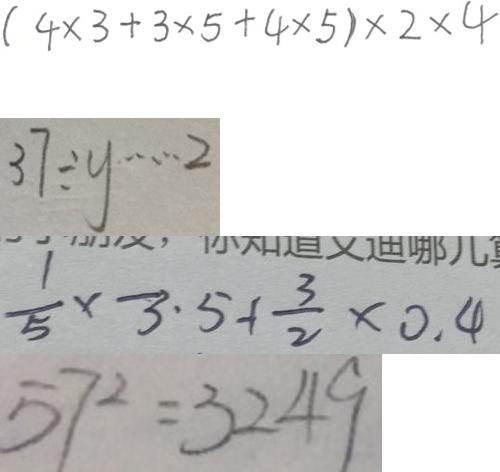Convert formula to latex. <formula><loc_0><loc_0><loc_500><loc_500>( 4 \times 3 + 3 \times 5 + 4 \times 5 ) \times 2 \times 4 
 3 7 \div y \cdots 2 
 \frac { 1 } { 5 } \times - 3 . 5 + \frac { 3 } { 2 } \times 0 . 4 
 5 7 ^ { 2 } = 3 2 4 9</formula> 